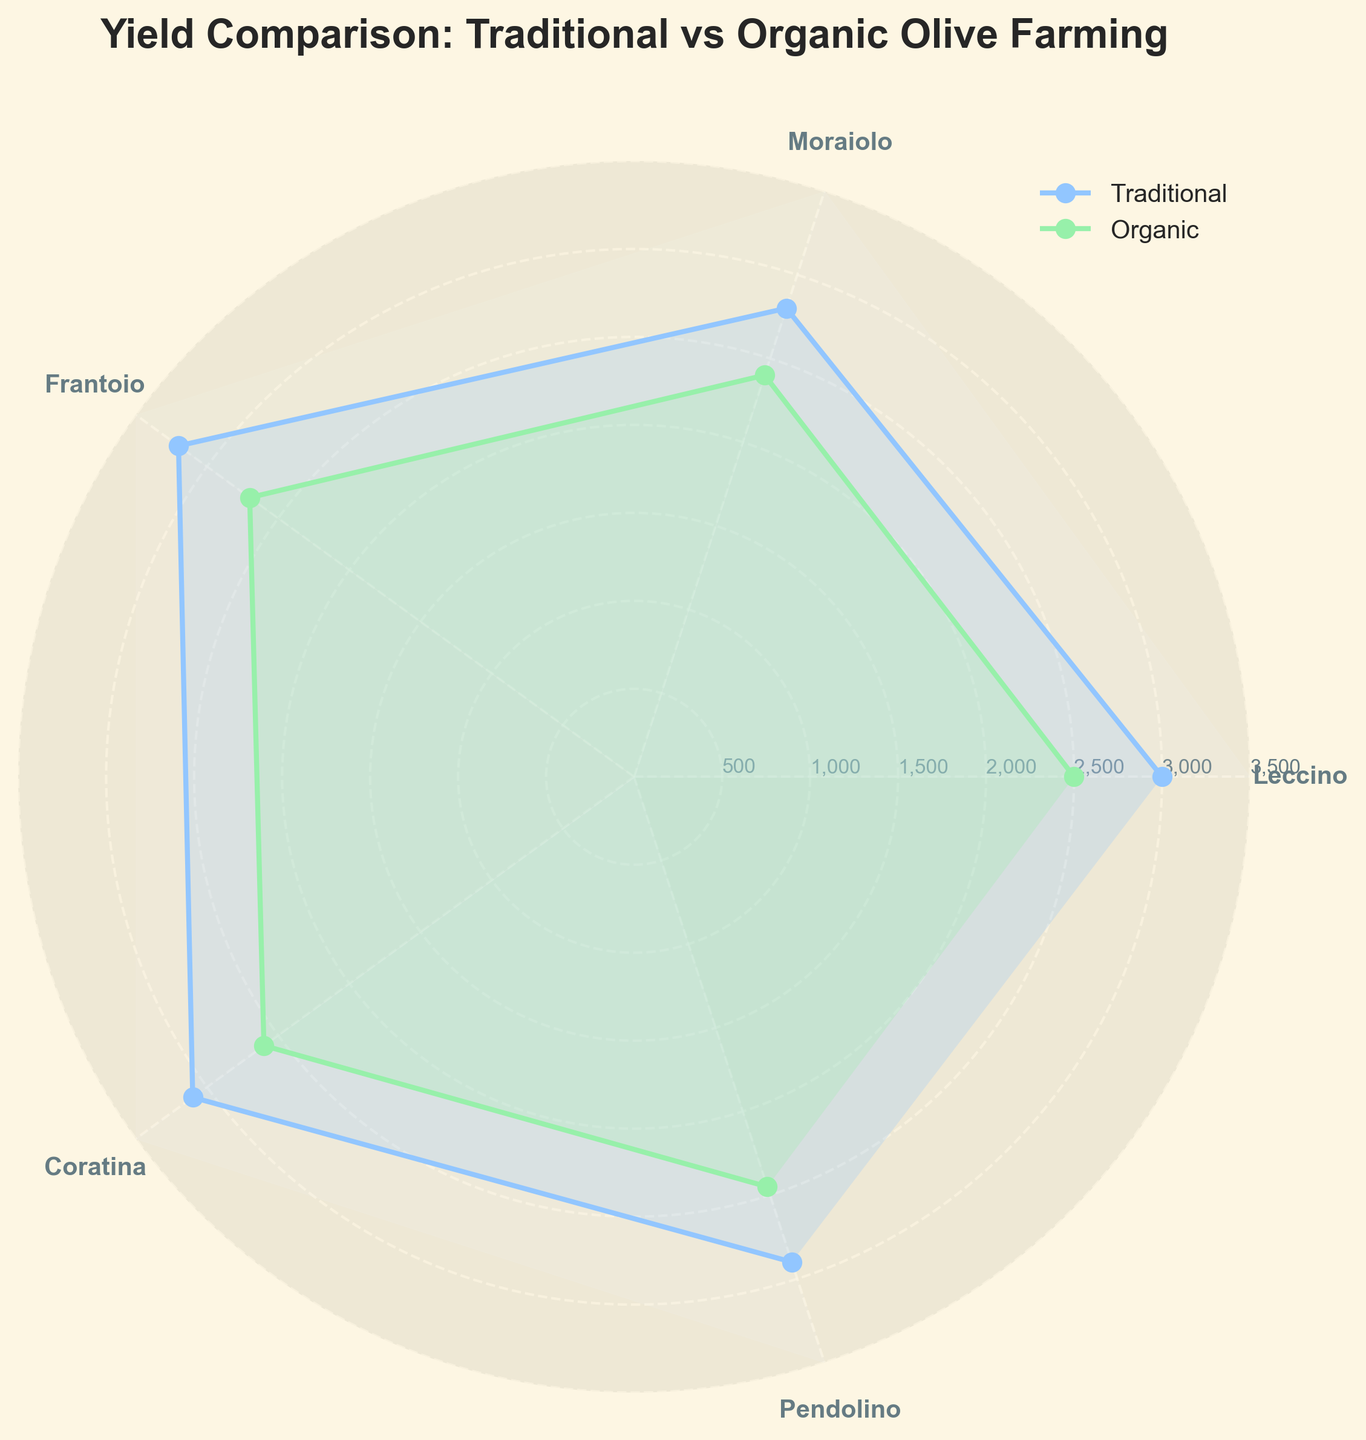Which farming method has the highest yield for Leccino olives? The polar chart shows data points for both traditional and organic farming methods for each olive type. For Leccino, the yield for traditional farming is higher, as indicated by a larger radial distance on the chart.
Answer: Traditional What is the difference in yield between traditional and organic Pendolino olives? The polar chart shows the yield for traditional Pendolino at 2900 kg per hectare and for organic Pendolino at 2450 kg per hectare. The difference is 2900 - 2450 = 450 kg per hectare.
Answer: 450 kg per hectare Which olive type has the smallest difference in yield between traditional and organic farming methods? By examining the differences in radial distances for each olive type, Coratina has the smallest difference in yield, with traditional farming at 3100 kg per hectare and organic farming at 2600 kg per hectare, a difference of 500.
Answer: Coratina Which farming method generally yields more olives? By looking at the overall radial distances for traditional and organic methods on the polar chart, traditional farming consistently shows higher yields across all olive types.
Answer: Traditional What is the average yield difference across all olive types between traditional and organic farming methods? Calculate the yield differences for each olive type and then find the average: (500 + 400 + 500 + 500 + 450) / 5 = 2350 / 5 = 470 kg per hectare.
Answer: 470 kg per hectare Which olive variety yields the most in organic farming? The polar chart shows that the Frantoio olive variety has the highest yield in organic farming at 2700 kg per hectare.
Answer: Frantoio What are the yields for Moraiolo in both farming methods? The polar chart shows that the yield for Moraiolo olives in traditional farming is 2800 kg per hectare and in organic farming is 2400 kg per hectare.
Answer: 2800 kg per hectare (traditional) and 2400 kg per hectare (organic) How do the yields for traditional Frantoio and Coratina compare? The polar chart indicates that the yield for Frantoio in traditional farming is 3200 kg per hectare, whereas for Coratina, it is 3100 kg per hectare, making Frantoio's yield slightly higher.
Answer: Frantoio yields more Is there any olive type where yield for organic farming exceeds traditional farming? The polar chart shows that for every olive variety, traditional farming yields are consistently higher than organic farming yields.
Answer: No What is the total yield for all olive types combined in traditional farming? Sum the yields for all olive types in traditional farming: 3000 + 2800 + 3200 + 3100 + 2900 = 15000 kg per hectare.
Answer: 15000 kg per hectare 